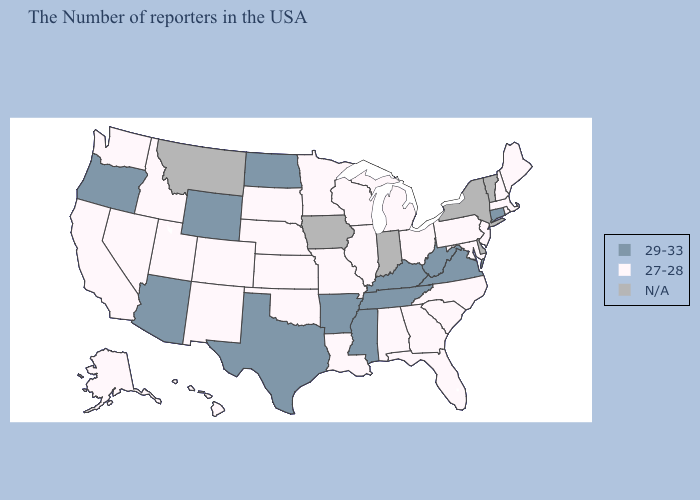What is the lowest value in the Northeast?
Quick response, please. 27-28. Name the states that have a value in the range N/A?
Concise answer only. Vermont, New York, Delaware, Indiana, Iowa, Montana. What is the highest value in states that border Alabama?
Concise answer only. 29-33. Name the states that have a value in the range N/A?
Short answer required. Vermont, New York, Delaware, Indiana, Iowa, Montana. Name the states that have a value in the range 29-33?
Give a very brief answer. Connecticut, Virginia, West Virginia, Kentucky, Tennessee, Mississippi, Arkansas, Texas, North Dakota, Wyoming, Arizona, Oregon. Does Connecticut have the highest value in the Northeast?
Quick response, please. Yes. Among the states that border New Mexico , which have the lowest value?
Answer briefly. Oklahoma, Colorado, Utah. Among the states that border Mississippi , which have the highest value?
Short answer required. Tennessee, Arkansas. What is the value of Kansas?
Keep it brief. 27-28. Name the states that have a value in the range 29-33?
Write a very short answer. Connecticut, Virginia, West Virginia, Kentucky, Tennessee, Mississippi, Arkansas, Texas, North Dakota, Wyoming, Arizona, Oregon. Name the states that have a value in the range N/A?
Be succinct. Vermont, New York, Delaware, Indiana, Iowa, Montana. What is the value of Michigan?
Answer briefly. 27-28. Which states have the lowest value in the Northeast?
Concise answer only. Maine, Massachusetts, Rhode Island, New Hampshire, New Jersey, Pennsylvania. What is the lowest value in the USA?
Concise answer only. 27-28. 